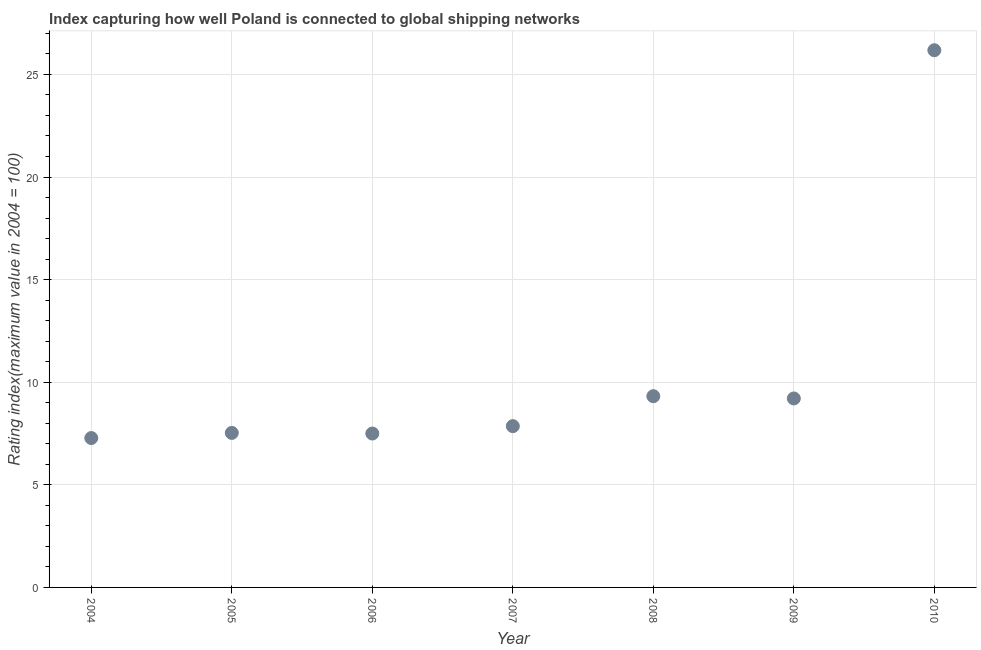What is the liner shipping connectivity index in 2010?
Give a very brief answer. 26.18. Across all years, what is the maximum liner shipping connectivity index?
Give a very brief answer. 26.18. Across all years, what is the minimum liner shipping connectivity index?
Ensure brevity in your answer.  7.28. What is the sum of the liner shipping connectivity index?
Provide a succinct answer. 74.88. What is the difference between the liner shipping connectivity index in 2004 and 2007?
Give a very brief answer. -0.58. What is the average liner shipping connectivity index per year?
Ensure brevity in your answer.  10.7. What is the median liner shipping connectivity index?
Your answer should be compact. 7.86. In how many years, is the liner shipping connectivity index greater than 22 ?
Your response must be concise. 1. Do a majority of the years between 2010 and 2007 (inclusive) have liner shipping connectivity index greater than 7 ?
Ensure brevity in your answer.  Yes. What is the ratio of the liner shipping connectivity index in 2009 to that in 2010?
Your answer should be very brief. 0.35. Is the difference between the liner shipping connectivity index in 2005 and 2008 greater than the difference between any two years?
Your answer should be very brief. No. What is the difference between the highest and the second highest liner shipping connectivity index?
Give a very brief answer. 16.86. Is the sum of the liner shipping connectivity index in 2005 and 2008 greater than the maximum liner shipping connectivity index across all years?
Provide a succinct answer. No. What is the difference between the highest and the lowest liner shipping connectivity index?
Provide a succinct answer. 18.9. How many dotlines are there?
Your response must be concise. 1. How many years are there in the graph?
Your answer should be very brief. 7. What is the difference between two consecutive major ticks on the Y-axis?
Provide a succinct answer. 5. Does the graph contain grids?
Offer a terse response. Yes. What is the title of the graph?
Provide a short and direct response. Index capturing how well Poland is connected to global shipping networks. What is the label or title of the X-axis?
Ensure brevity in your answer.  Year. What is the label or title of the Y-axis?
Keep it short and to the point. Rating index(maximum value in 2004 = 100). What is the Rating index(maximum value in 2004 = 100) in 2004?
Your response must be concise. 7.28. What is the Rating index(maximum value in 2004 = 100) in 2005?
Your answer should be compact. 7.53. What is the Rating index(maximum value in 2004 = 100) in 2006?
Provide a succinct answer. 7.5. What is the Rating index(maximum value in 2004 = 100) in 2007?
Provide a short and direct response. 7.86. What is the Rating index(maximum value in 2004 = 100) in 2008?
Offer a very short reply. 9.32. What is the Rating index(maximum value in 2004 = 100) in 2009?
Make the answer very short. 9.21. What is the Rating index(maximum value in 2004 = 100) in 2010?
Ensure brevity in your answer.  26.18. What is the difference between the Rating index(maximum value in 2004 = 100) in 2004 and 2005?
Offer a terse response. -0.25. What is the difference between the Rating index(maximum value in 2004 = 100) in 2004 and 2006?
Make the answer very short. -0.22. What is the difference between the Rating index(maximum value in 2004 = 100) in 2004 and 2007?
Provide a short and direct response. -0.58. What is the difference between the Rating index(maximum value in 2004 = 100) in 2004 and 2008?
Keep it short and to the point. -2.04. What is the difference between the Rating index(maximum value in 2004 = 100) in 2004 and 2009?
Your answer should be compact. -1.93. What is the difference between the Rating index(maximum value in 2004 = 100) in 2004 and 2010?
Your answer should be very brief. -18.9. What is the difference between the Rating index(maximum value in 2004 = 100) in 2005 and 2006?
Your answer should be very brief. 0.03. What is the difference between the Rating index(maximum value in 2004 = 100) in 2005 and 2007?
Make the answer very short. -0.33. What is the difference between the Rating index(maximum value in 2004 = 100) in 2005 and 2008?
Offer a very short reply. -1.79. What is the difference between the Rating index(maximum value in 2004 = 100) in 2005 and 2009?
Make the answer very short. -1.68. What is the difference between the Rating index(maximum value in 2004 = 100) in 2005 and 2010?
Your answer should be very brief. -18.65. What is the difference between the Rating index(maximum value in 2004 = 100) in 2006 and 2007?
Ensure brevity in your answer.  -0.36. What is the difference between the Rating index(maximum value in 2004 = 100) in 2006 and 2008?
Ensure brevity in your answer.  -1.82. What is the difference between the Rating index(maximum value in 2004 = 100) in 2006 and 2009?
Provide a short and direct response. -1.71. What is the difference between the Rating index(maximum value in 2004 = 100) in 2006 and 2010?
Provide a short and direct response. -18.68. What is the difference between the Rating index(maximum value in 2004 = 100) in 2007 and 2008?
Your response must be concise. -1.46. What is the difference between the Rating index(maximum value in 2004 = 100) in 2007 and 2009?
Provide a short and direct response. -1.35. What is the difference between the Rating index(maximum value in 2004 = 100) in 2007 and 2010?
Your answer should be compact. -18.32. What is the difference between the Rating index(maximum value in 2004 = 100) in 2008 and 2009?
Make the answer very short. 0.11. What is the difference between the Rating index(maximum value in 2004 = 100) in 2008 and 2010?
Make the answer very short. -16.86. What is the difference between the Rating index(maximum value in 2004 = 100) in 2009 and 2010?
Ensure brevity in your answer.  -16.97. What is the ratio of the Rating index(maximum value in 2004 = 100) in 2004 to that in 2005?
Make the answer very short. 0.97. What is the ratio of the Rating index(maximum value in 2004 = 100) in 2004 to that in 2007?
Make the answer very short. 0.93. What is the ratio of the Rating index(maximum value in 2004 = 100) in 2004 to that in 2008?
Offer a very short reply. 0.78. What is the ratio of the Rating index(maximum value in 2004 = 100) in 2004 to that in 2009?
Offer a very short reply. 0.79. What is the ratio of the Rating index(maximum value in 2004 = 100) in 2004 to that in 2010?
Your answer should be very brief. 0.28. What is the ratio of the Rating index(maximum value in 2004 = 100) in 2005 to that in 2006?
Keep it short and to the point. 1. What is the ratio of the Rating index(maximum value in 2004 = 100) in 2005 to that in 2007?
Your answer should be compact. 0.96. What is the ratio of the Rating index(maximum value in 2004 = 100) in 2005 to that in 2008?
Provide a succinct answer. 0.81. What is the ratio of the Rating index(maximum value in 2004 = 100) in 2005 to that in 2009?
Your answer should be compact. 0.82. What is the ratio of the Rating index(maximum value in 2004 = 100) in 2005 to that in 2010?
Offer a very short reply. 0.29. What is the ratio of the Rating index(maximum value in 2004 = 100) in 2006 to that in 2007?
Your answer should be compact. 0.95. What is the ratio of the Rating index(maximum value in 2004 = 100) in 2006 to that in 2008?
Keep it short and to the point. 0.81. What is the ratio of the Rating index(maximum value in 2004 = 100) in 2006 to that in 2009?
Offer a very short reply. 0.81. What is the ratio of the Rating index(maximum value in 2004 = 100) in 2006 to that in 2010?
Offer a very short reply. 0.29. What is the ratio of the Rating index(maximum value in 2004 = 100) in 2007 to that in 2008?
Provide a succinct answer. 0.84. What is the ratio of the Rating index(maximum value in 2004 = 100) in 2007 to that in 2009?
Provide a succinct answer. 0.85. What is the ratio of the Rating index(maximum value in 2004 = 100) in 2008 to that in 2009?
Give a very brief answer. 1.01. What is the ratio of the Rating index(maximum value in 2004 = 100) in 2008 to that in 2010?
Keep it short and to the point. 0.36. What is the ratio of the Rating index(maximum value in 2004 = 100) in 2009 to that in 2010?
Your answer should be compact. 0.35. 